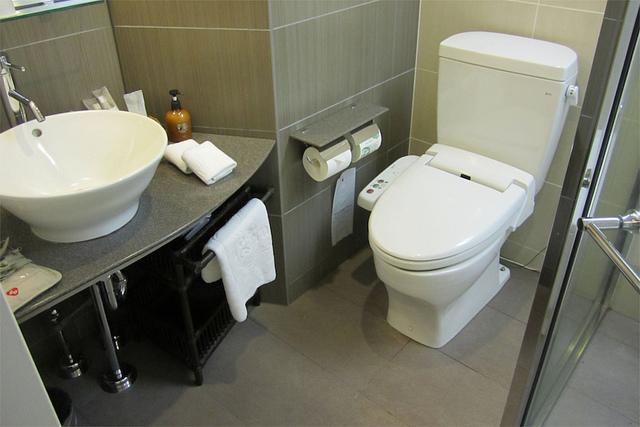What do the buttons to the right of the tissue rolls control?

Choices:
A) temperature
B) lights
C) toilet
D) radio toilet 